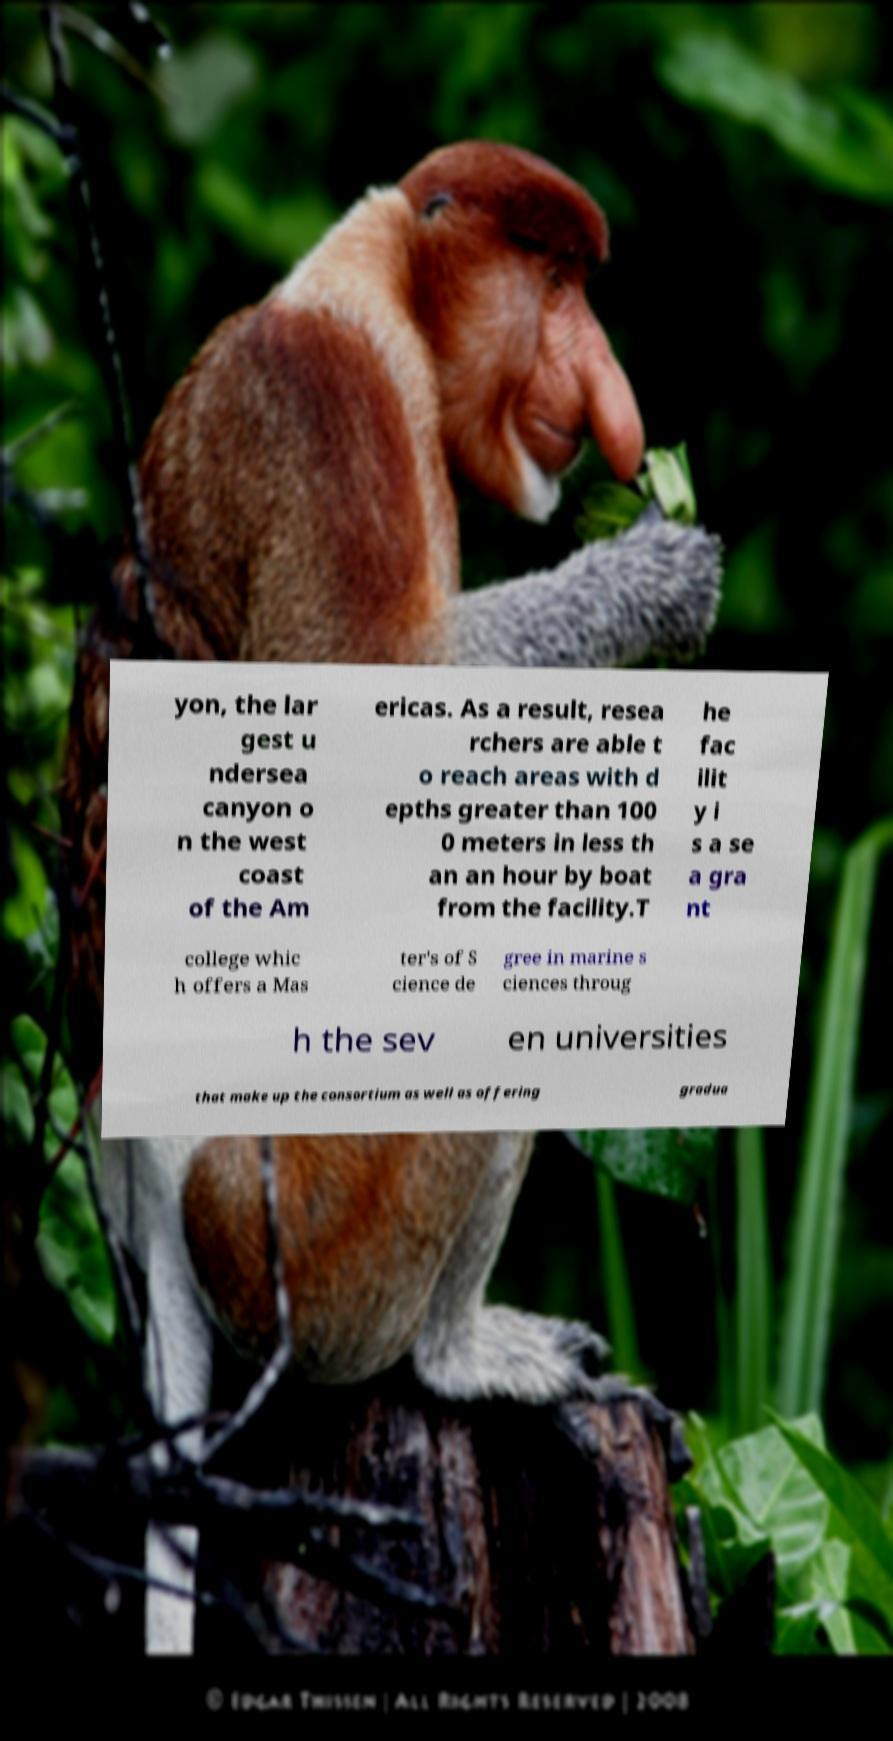Can you accurately transcribe the text from the provided image for me? yon, the lar gest u ndersea canyon o n the west coast of the Am ericas. As a result, resea rchers are able t o reach areas with d epths greater than 100 0 meters in less th an an hour by boat from the facility.T he fac ilit y i s a se a gra nt college whic h offers a Mas ter's of S cience de gree in marine s ciences throug h the sev en universities that make up the consortium as well as offering gradua 